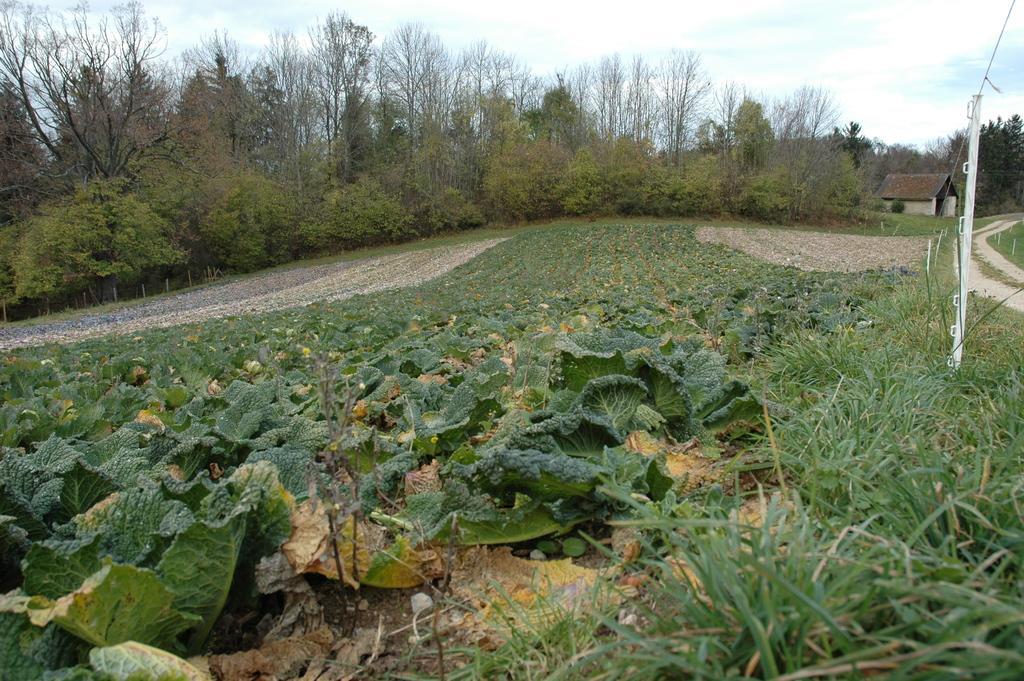Describe this image in one or two sentences. In this picture there are two ways on the right and left side of the image and there is a house on the right side of the image and there is greenery around the area of the image. 